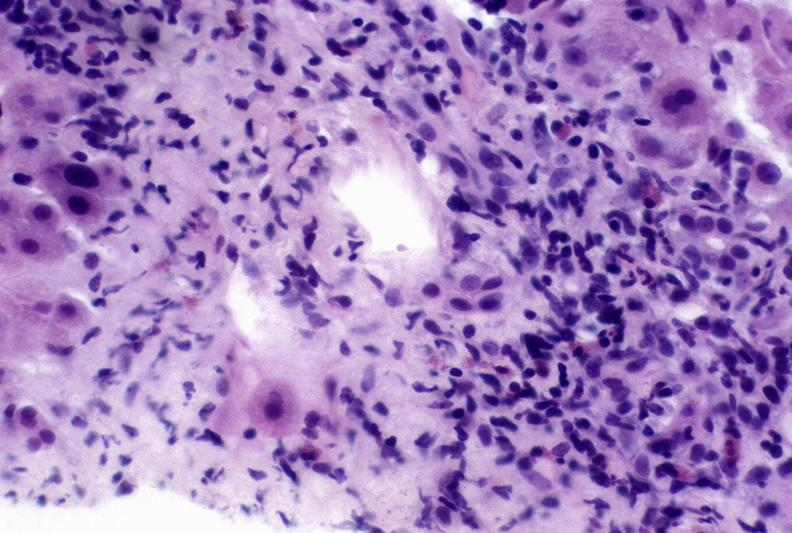what does this image show?
Answer the question using a single word or phrase. Autoimmune hepatitis 